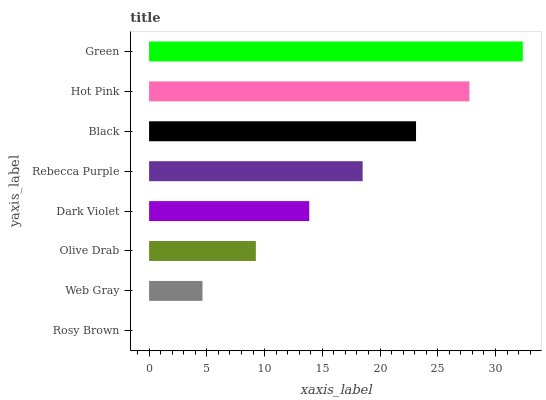Is Rosy Brown the minimum?
Answer yes or no. Yes. Is Green the maximum?
Answer yes or no. Yes. Is Web Gray the minimum?
Answer yes or no. No. Is Web Gray the maximum?
Answer yes or no. No. Is Web Gray greater than Rosy Brown?
Answer yes or no. Yes. Is Rosy Brown less than Web Gray?
Answer yes or no. Yes. Is Rosy Brown greater than Web Gray?
Answer yes or no. No. Is Web Gray less than Rosy Brown?
Answer yes or no. No. Is Rebecca Purple the high median?
Answer yes or no. Yes. Is Dark Violet the low median?
Answer yes or no. Yes. Is Dark Violet the high median?
Answer yes or no. No. Is Hot Pink the low median?
Answer yes or no. No. 